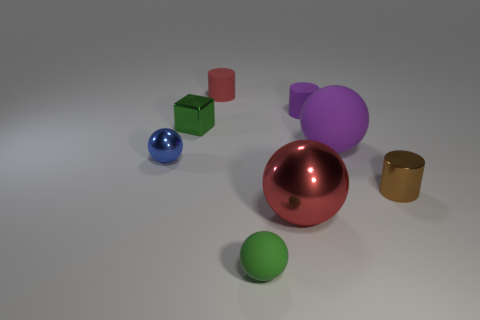There is a cylinder that is the same color as the big metallic sphere; what is its material?
Your answer should be very brief. Rubber. There is a big object to the right of the big metal object that is in front of the large thing to the right of the big red ball; what is its shape?
Your answer should be very brief. Sphere. What number of brown things are made of the same material as the green cube?
Offer a terse response. 1. There is a sphere behind the small blue metal ball; how many large spheres are on the left side of it?
Make the answer very short. 1. What number of big yellow matte cylinders are there?
Offer a very short reply. 0. Is the green sphere made of the same material as the tiny cylinder in front of the green shiny object?
Ensure brevity in your answer.  No. Does the matte sphere that is in front of the tiny shiny sphere have the same color as the tiny block?
Give a very brief answer. Yes. The small cylinder that is behind the blue metal thing and right of the green matte ball is made of what material?
Make the answer very short. Rubber. What is the size of the red metallic sphere?
Your answer should be compact. Large. Do the tiny block and the matte ball in front of the large matte thing have the same color?
Make the answer very short. Yes. 